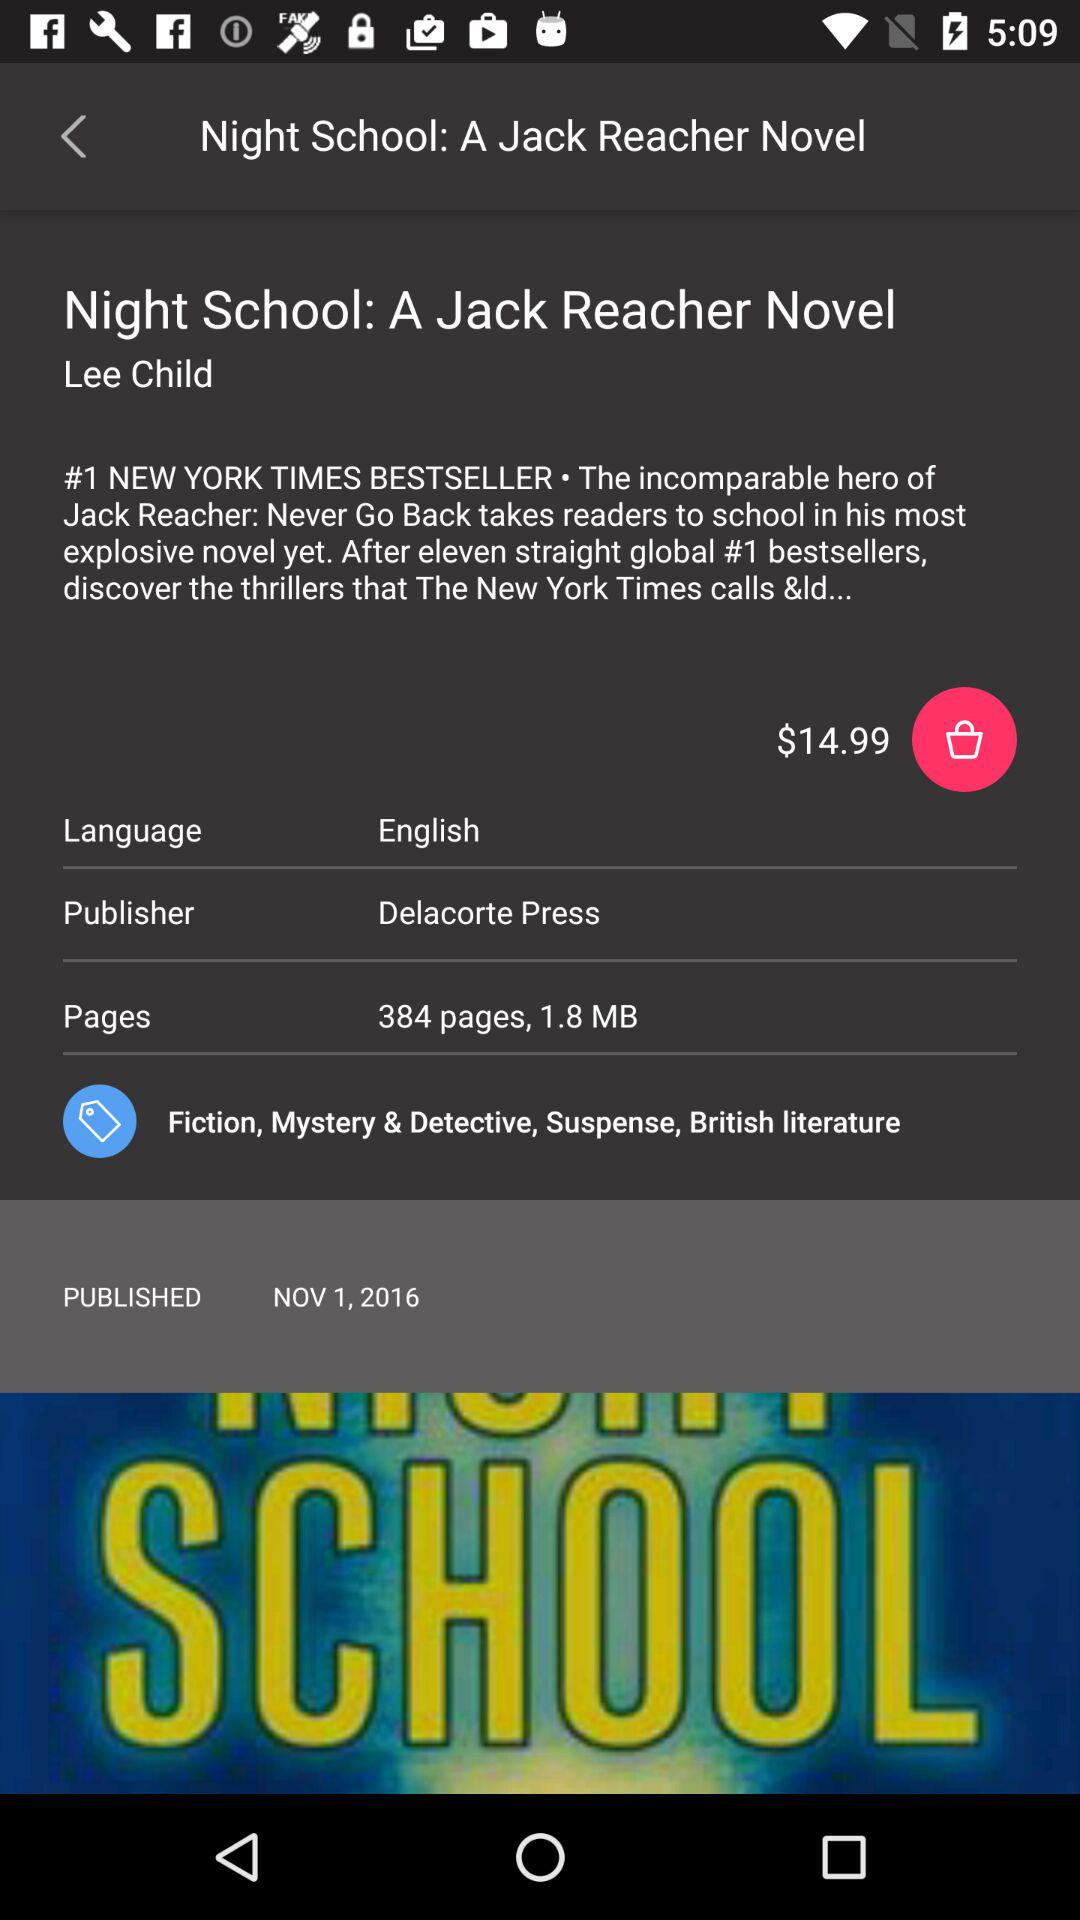Who is the publisher? The publisher is Delacorte Press. 